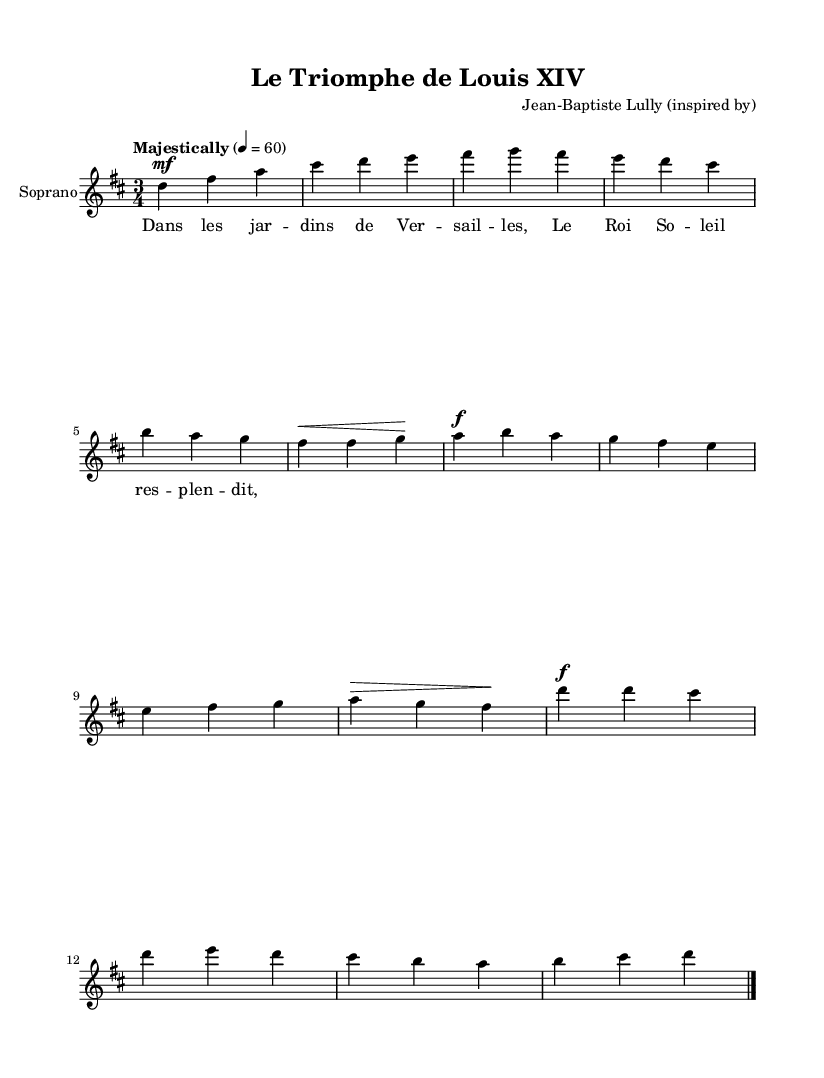What is the key signature of this music? The key signature is indicated at the beginning of the staff, where there are two sharps, which corresponds to D major.
Answer: D major What is the time signature of this music? The time signature is shown at the beginning of the score, represented as a fraction. Here, it is noted as three beats per measure, which indicates a 3/4 time signature.
Answer: 3/4 What is the tempo marking for this piece? The tempo marking instructs how fast the music should be played and is written above the staff. In this case, it says "Majestically," with a quarter note equal to 60 beats per minute.
Answer: Majestically How many measures are in the excerpt presented? By counting the sets of vertical lines separating each measure shown in the score, one can determine the number of measures. There are 8 measures total in the music excerpt provided.
Answer: 8 What dynamic marking is used at the beginning of the introduction? The dynamic marking is indicated by the abbreviation followed by a specific dynamic level. In the introduction, the dynamic marking is "mf," which stands for mezzo-forte, indicating a moderately loud volume.
Answer: mezzo-forte What text is associated with the soprano part in this score? The lyrics for the soprano part are directly placed below the notes. The lyric provided starts with "Dans les jar -- dins de Ver -- sail -- les," which depicts a descriptive phrase.
Answer: Dans les jar -- dins de Ver -- sail -- les What type of opera is represented in this music? The composition and the context hint at a specific era and style that is characteristic of French Baroque operas, known for elaborate musical storytelling around historical events and royal courts.
Answer: French Baroque opera 